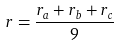Convert formula to latex. <formula><loc_0><loc_0><loc_500><loc_500>r = \frac { r _ { a } + r _ { b } + r _ { c } } { 9 }</formula> 